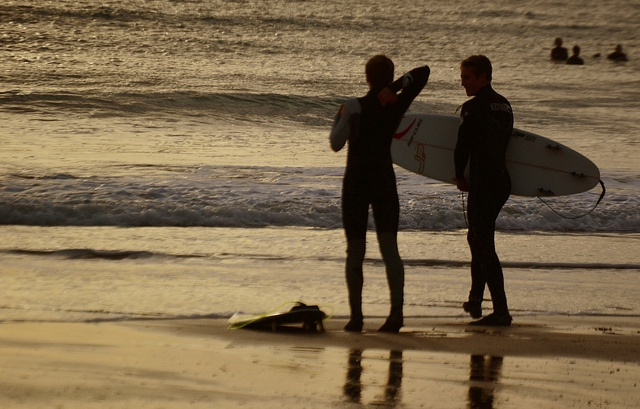Describe the objects in this image and their specific colors. I can see people in tan, black, and gray tones, people in tan, black, and gray tones, surfboard in tan, black, and gray tones, surfboard in tan, black, and olive tones, and people in tan, black, and gray tones in this image. 